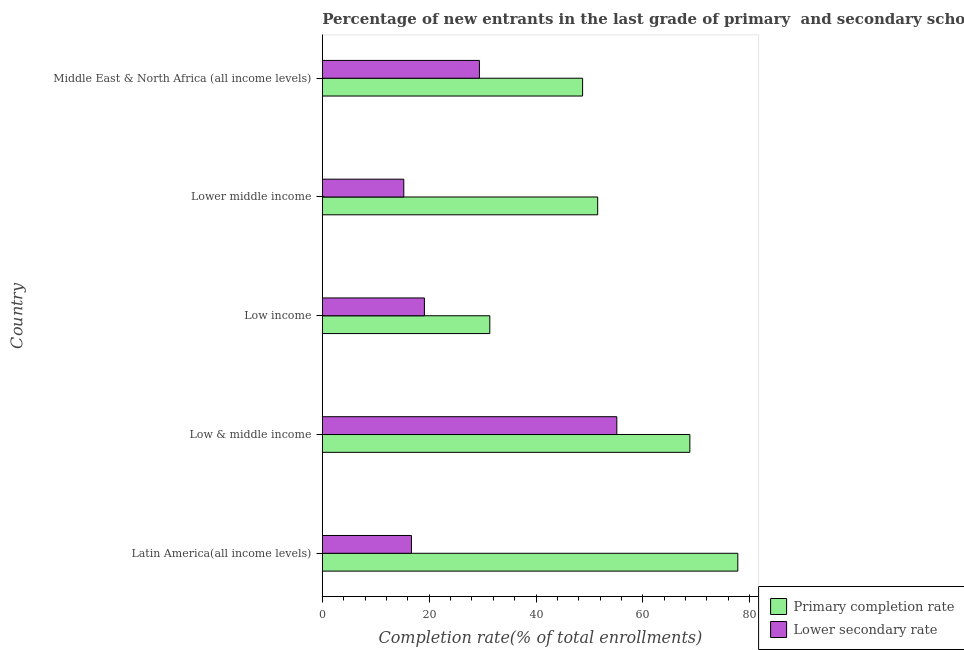How many different coloured bars are there?
Offer a very short reply. 2. How many groups of bars are there?
Give a very brief answer. 5. Are the number of bars per tick equal to the number of legend labels?
Give a very brief answer. Yes. Are the number of bars on each tick of the Y-axis equal?
Give a very brief answer. Yes. How many bars are there on the 4th tick from the top?
Ensure brevity in your answer.  2. In how many cases, is the number of bars for a given country not equal to the number of legend labels?
Make the answer very short. 0. What is the completion rate in secondary schools in Middle East & North Africa (all income levels)?
Provide a succinct answer. 29.41. Across all countries, what is the maximum completion rate in secondary schools?
Ensure brevity in your answer.  55.13. Across all countries, what is the minimum completion rate in primary schools?
Offer a terse response. 31.35. In which country was the completion rate in primary schools maximum?
Your answer should be very brief. Latin America(all income levels). In which country was the completion rate in secondary schools minimum?
Offer a terse response. Lower middle income. What is the total completion rate in primary schools in the graph?
Provide a succinct answer. 278.2. What is the difference between the completion rate in secondary schools in Latin America(all income levels) and that in Middle East & North Africa (all income levels)?
Your response must be concise. -12.73. What is the difference between the completion rate in primary schools in Middle East & North Africa (all income levels) and the completion rate in secondary schools in Latin America(all income levels)?
Your answer should be very brief. 32.04. What is the average completion rate in primary schools per country?
Make the answer very short. 55.64. What is the difference between the completion rate in primary schools and completion rate in secondary schools in Middle East & North Africa (all income levels)?
Provide a short and direct response. 19.31. What is the ratio of the completion rate in secondary schools in Latin America(all income levels) to that in Low income?
Offer a terse response. 0.87. What is the difference between the highest and the second highest completion rate in secondary schools?
Provide a short and direct response. 25.72. What is the difference between the highest and the lowest completion rate in primary schools?
Your answer should be compact. 46.42. What does the 1st bar from the top in Low income represents?
Ensure brevity in your answer.  Lower secondary rate. What does the 1st bar from the bottom in Low & middle income represents?
Ensure brevity in your answer.  Primary completion rate. How many bars are there?
Your answer should be compact. 10. Are all the bars in the graph horizontal?
Ensure brevity in your answer.  Yes. How many countries are there in the graph?
Keep it short and to the point. 5. What is the difference between two consecutive major ticks on the X-axis?
Provide a short and direct response. 20. Does the graph contain any zero values?
Keep it short and to the point. No. Does the graph contain grids?
Give a very brief answer. No. How many legend labels are there?
Your answer should be very brief. 2. What is the title of the graph?
Your answer should be compact. Percentage of new entrants in the last grade of primary  and secondary schools in countries. What is the label or title of the X-axis?
Your answer should be compact. Completion rate(% of total enrollments). What is the label or title of the Y-axis?
Your response must be concise. Country. What is the Completion rate(% of total enrollments) of Primary completion rate in Latin America(all income levels)?
Keep it short and to the point. 77.78. What is the Completion rate(% of total enrollments) of Lower secondary rate in Latin America(all income levels)?
Your answer should be very brief. 16.68. What is the Completion rate(% of total enrollments) of Primary completion rate in Low & middle income?
Provide a short and direct response. 68.8. What is the Completion rate(% of total enrollments) in Lower secondary rate in Low & middle income?
Give a very brief answer. 55.13. What is the Completion rate(% of total enrollments) in Primary completion rate in Low income?
Give a very brief answer. 31.35. What is the Completion rate(% of total enrollments) of Lower secondary rate in Low income?
Provide a succinct answer. 19.11. What is the Completion rate(% of total enrollments) of Primary completion rate in Lower middle income?
Your answer should be very brief. 51.55. What is the Completion rate(% of total enrollments) in Lower secondary rate in Lower middle income?
Your response must be concise. 15.25. What is the Completion rate(% of total enrollments) of Primary completion rate in Middle East & North Africa (all income levels)?
Your response must be concise. 48.72. What is the Completion rate(% of total enrollments) of Lower secondary rate in Middle East & North Africa (all income levels)?
Your answer should be very brief. 29.41. Across all countries, what is the maximum Completion rate(% of total enrollments) in Primary completion rate?
Provide a short and direct response. 77.78. Across all countries, what is the maximum Completion rate(% of total enrollments) of Lower secondary rate?
Keep it short and to the point. 55.13. Across all countries, what is the minimum Completion rate(% of total enrollments) in Primary completion rate?
Offer a very short reply. 31.35. Across all countries, what is the minimum Completion rate(% of total enrollments) in Lower secondary rate?
Make the answer very short. 15.25. What is the total Completion rate(% of total enrollments) of Primary completion rate in the graph?
Provide a short and direct response. 278.2. What is the total Completion rate(% of total enrollments) in Lower secondary rate in the graph?
Offer a very short reply. 135.58. What is the difference between the Completion rate(% of total enrollments) in Primary completion rate in Latin America(all income levels) and that in Low & middle income?
Make the answer very short. 8.98. What is the difference between the Completion rate(% of total enrollments) in Lower secondary rate in Latin America(all income levels) and that in Low & middle income?
Make the answer very short. -38.45. What is the difference between the Completion rate(% of total enrollments) in Primary completion rate in Latin America(all income levels) and that in Low income?
Provide a succinct answer. 46.42. What is the difference between the Completion rate(% of total enrollments) in Lower secondary rate in Latin America(all income levels) and that in Low income?
Make the answer very short. -2.43. What is the difference between the Completion rate(% of total enrollments) in Primary completion rate in Latin America(all income levels) and that in Lower middle income?
Give a very brief answer. 26.23. What is the difference between the Completion rate(% of total enrollments) of Lower secondary rate in Latin America(all income levels) and that in Lower middle income?
Your answer should be very brief. 1.43. What is the difference between the Completion rate(% of total enrollments) in Primary completion rate in Latin America(all income levels) and that in Middle East & North Africa (all income levels)?
Give a very brief answer. 29.06. What is the difference between the Completion rate(% of total enrollments) in Lower secondary rate in Latin America(all income levels) and that in Middle East & North Africa (all income levels)?
Offer a terse response. -12.73. What is the difference between the Completion rate(% of total enrollments) in Primary completion rate in Low & middle income and that in Low income?
Offer a terse response. 37.45. What is the difference between the Completion rate(% of total enrollments) in Lower secondary rate in Low & middle income and that in Low income?
Offer a very short reply. 36.02. What is the difference between the Completion rate(% of total enrollments) in Primary completion rate in Low & middle income and that in Lower middle income?
Provide a short and direct response. 17.25. What is the difference between the Completion rate(% of total enrollments) of Lower secondary rate in Low & middle income and that in Lower middle income?
Ensure brevity in your answer.  39.88. What is the difference between the Completion rate(% of total enrollments) in Primary completion rate in Low & middle income and that in Middle East & North Africa (all income levels)?
Your answer should be compact. 20.08. What is the difference between the Completion rate(% of total enrollments) of Lower secondary rate in Low & middle income and that in Middle East & North Africa (all income levels)?
Make the answer very short. 25.72. What is the difference between the Completion rate(% of total enrollments) in Primary completion rate in Low income and that in Lower middle income?
Make the answer very short. -20.19. What is the difference between the Completion rate(% of total enrollments) of Lower secondary rate in Low income and that in Lower middle income?
Provide a short and direct response. 3.86. What is the difference between the Completion rate(% of total enrollments) in Primary completion rate in Low income and that in Middle East & North Africa (all income levels)?
Provide a succinct answer. -17.37. What is the difference between the Completion rate(% of total enrollments) of Lower secondary rate in Low income and that in Middle East & North Africa (all income levels)?
Give a very brief answer. -10.3. What is the difference between the Completion rate(% of total enrollments) of Primary completion rate in Lower middle income and that in Middle East & North Africa (all income levels)?
Your response must be concise. 2.83. What is the difference between the Completion rate(% of total enrollments) in Lower secondary rate in Lower middle income and that in Middle East & North Africa (all income levels)?
Your answer should be compact. -14.16. What is the difference between the Completion rate(% of total enrollments) of Primary completion rate in Latin America(all income levels) and the Completion rate(% of total enrollments) of Lower secondary rate in Low & middle income?
Make the answer very short. 22.65. What is the difference between the Completion rate(% of total enrollments) in Primary completion rate in Latin America(all income levels) and the Completion rate(% of total enrollments) in Lower secondary rate in Low income?
Your response must be concise. 58.67. What is the difference between the Completion rate(% of total enrollments) in Primary completion rate in Latin America(all income levels) and the Completion rate(% of total enrollments) in Lower secondary rate in Lower middle income?
Offer a very short reply. 62.53. What is the difference between the Completion rate(% of total enrollments) of Primary completion rate in Latin America(all income levels) and the Completion rate(% of total enrollments) of Lower secondary rate in Middle East & North Africa (all income levels)?
Your response must be concise. 48.37. What is the difference between the Completion rate(% of total enrollments) in Primary completion rate in Low & middle income and the Completion rate(% of total enrollments) in Lower secondary rate in Low income?
Provide a succinct answer. 49.69. What is the difference between the Completion rate(% of total enrollments) of Primary completion rate in Low & middle income and the Completion rate(% of total enrollments) of Lower secondary rate in Lower middle income?
Ensure brevity in your answer.  53.55. What is the difference between the Completion rate(% of total enrollments) of Primary completion rate in Low & middle income and the Completion rate(% of total enrollments) of Lower secondary rate in Middle East & North Africa (all income levels)?
Provide a succinct answer. 39.39. What is the difference between the Completion rate(% of total enrollments) of Primary completion rate in Low income and the Completion rate(% of total enrollments) of Lower secondary rate in Lower middle income?
Keep it short and to the point. 16.1. What is the difference between the Completion rate(% of total enrollments) in Primary completion rate in Low income and the Completion rate(% of total enrollments) in Lower secondary rate in Middle East & North Africa (all income levels)?
Provide a short and direct response. 1.95. What is the difference between the Completion rate(% of total enrollments) in Primary completion rate in Lower middle income and the Completion rate(% of total enrollments) in Lower secondary rate in Middle East & North Africa (all income levels)?
Provide a short and direct response. 22.14. What is the average Completion rate(% of total enrollments) of Primary completion rate per country?
Make the answer very short. 55.64. What is the average Completion rate(% of total enrollments) in Lower secondary rate per country?
Provide a short and direct response. 27.12. What is the difference between the Completion rate(% of total enrollments) of Primary completion rate and Completion rate(% of total enrollments) of Lower secondary rate in Latin America(all income levels)?
Ensure brevity in your answer.  61.1. What is the difference between the Completion rate(% of total enrollments) of Primary completion rate and Completion rate(% of total enrollments) of Lower secondary rate in Low & middle income?
Your response must be concise. 13.67. What is the difference between the Completion rate(% of total enrollments) in Primary completion rate and Completion rate(% of total enrollments) in Lower secondary rate in Low income?
Your response must be concise. 12.25. What is the difference between the Completion rate(% of total enrollments) in Primary completion rate and Completion rate(% of total enrollments) in Lower secondary rate in Lower middle income?
Keep it short and to the point. 36.3. What is the difference between the Completion rate(% of total enrollments) in Primary completion rate and Completion rate(% of total enrollments) in Lower secondary rate in Middle East & North Africa (all income levels)?
Your answer should be very brief. 19.31. What is the ratio of the Completion rate(% of total enrollments) in Primary completion rate in Latin America(all income levels) to that in Low & middle income?
Make the answer very short. 1.13. What is the ratio of the Completion rate(% of total enrollments) in Lower secondary rate in Latin America(all income levels) to that in Low & middle income?
Keep it short and to the point. 0.3. What is the ratio of the Completion rate(% of total enrollments) of Primary completion rate in Latin America(all income levels) to that in Low income?
Give a very brief answer. 2.48. What is the ratio of the Completion rate(% of total enrollments) in Lower secondary rate in Latin America(all income levels) to that in Low income?
Provide a succinct answer. 0.87. What is the ratio of the Completion rate(% of total enrollments) in Primary completion rate in Latin America(all income levels) to that in Lower middle income?
Your answer should be very brief. 1.51. What is the ratio of the Completion rate(% of total enrollments) of Lower secondary rate in Latin America(all income levels) to that in Lower middle income?
Keep it short and to the point. 1.09. What is the ratio of the Completion rate(% of total enrollments) of Primary completion rate in Latin America(all income levels) to that in Middle East & North Africa (all income levels)?
Offer a very short reply. 1.6. What is the ratio of the Completion rate(% of total enrollments) of Lower secondary rate in Latin America(all income levels) to that in Middle East & North Africa (all income levels)?
Give a very brief answer. 0.57. What is the ratio of the Completion rate(% of total enrollments) in Primary completion rate in Low & middle income to that in Low income?
Keep it short and to the point. 2.19. What is the ratio of the Completion rate(% of total enrollments) in Lower secondary rate in Low & middle income to that in Low income?
Keep it short and to the point. 2.89. What is the ratio of the Completion rate(% of total enrollments) in Primary completion rate in Low & middle income to that in Lower middle income?
Your answer should be very brief. 1.33. What is the ratio of the Completion rate(% of total enrollments) in Lower secondary rate in Low & middle income to that in Lower middle income?
Keep it short and to the point. 3.62. What is the ratio of the Completion rate(% of total enrollments) of Primary completion rate in Low & middle income to that in Middle East & North Africa (all income levels)?
Your answer should be compact. 1.41. What is the ratio of the Completion rate(% of total enrollments) of Lower secondary rate in Low & middle income to that in Middle East & North Africa (all income levels)?
Offer a terse response. 1.87. What is the ratio of the Completion rate(% of total enrollments) of Primary completion rate in Low income to that in Lower middle income?
Give a very brief answer. 0.61. What is the ratio of the Completion rate(% of total enrollments) of Lower secondary rate in Low income to that in Lower middle income?
Provide a short and direct response. 1.25. What is the ratio of the Completion rate(% of total enrollments) of Primary completion rate in Low income to that in Middle East & North Africa (all income levels)?
Your answer should be compact. 0.64. What is the ratio of the Completion rate(% of total enrollments) of Lower secondary rate in Low income to that in Middle East & North Africa (all income levels)?
Give a very brief answer. 0.65. What is the ratio of the Completion rate(% of total enrollments) in Primary completion rate in Lower middle income to that in Middle East & North Africa (all income levels)?
Your answer should be compact. 1.06. What is the ratio of the Completion rate(% of total enrollments) of Lower secondary rate in Lower middle income to that in Middle East & North Africa (all income levels)?
Your answer should be compact. 0.52. What is the difference between the highest and the second highest Completion rate(% of total enrollments) of Primary completion rate?
Your answer should be compact. 8.98. What is the difference between the highest and the second highest Completion rate(% of total enrollments) of Lower secondary rate?
Your response must be concise. 25.72. What is the difference between the highest and the lowest Completion rate(% of total enrollments) in Primary completion rate?
Provide a short and direct response. 46.42. What is the difference between the highest and the lowest Completion rate(% of total enrollments) of Lower secondary rate?
Your answer should be very brief. 39.88. 